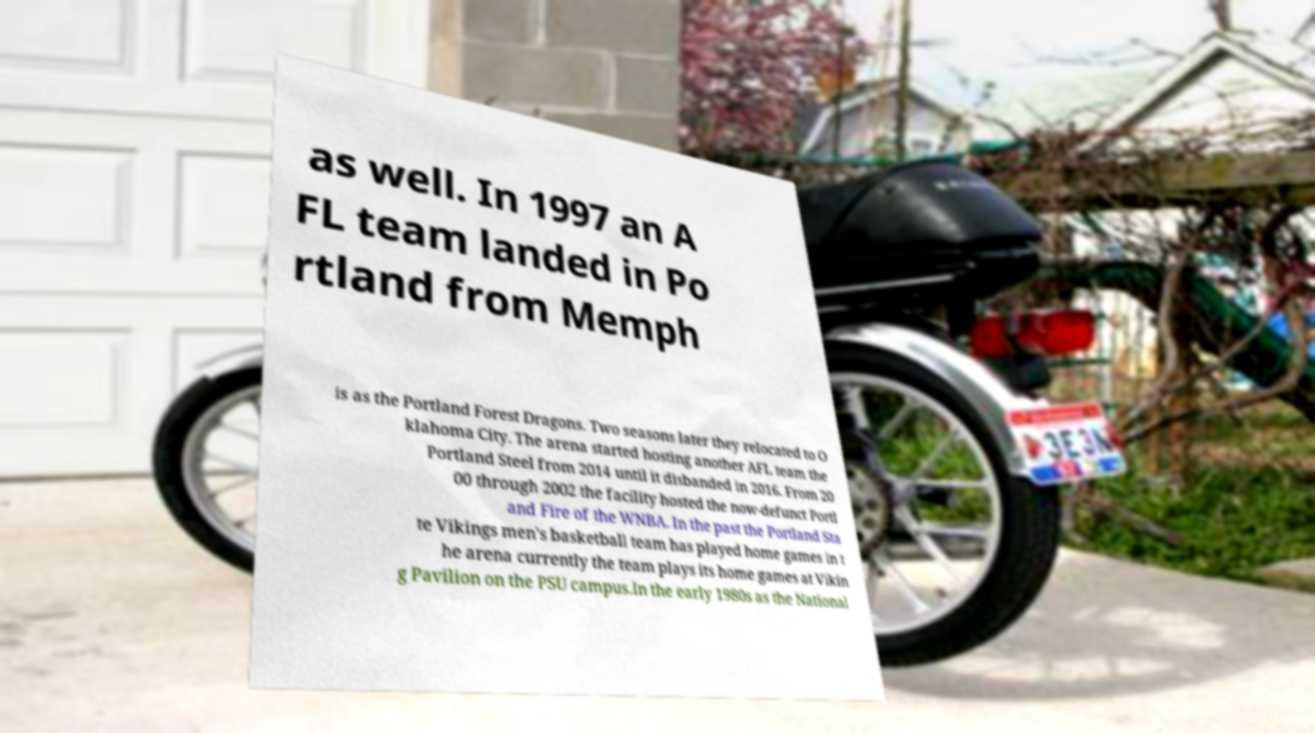Could you assist in decoding the text presented in this image and type it out clearly? as well. In 1997 an A FL team landed in Po rtland from Memph is as the Portland Forest Dragons. Two seasons later they relocated to O klahoma City. The arena started hosting another AFL team the Portland Steel from 2014 until it disbanded in 2016. From 20 00 through 2002 the facility hosted the now-defunct Portl and Fire of the WNBA. In the past the Portland Sta te Vikings men's basketball team has played home games in t he arena currently the team plays its home games at Vikin g Pavilion on the PSU campus.In the early 1980s as the National 